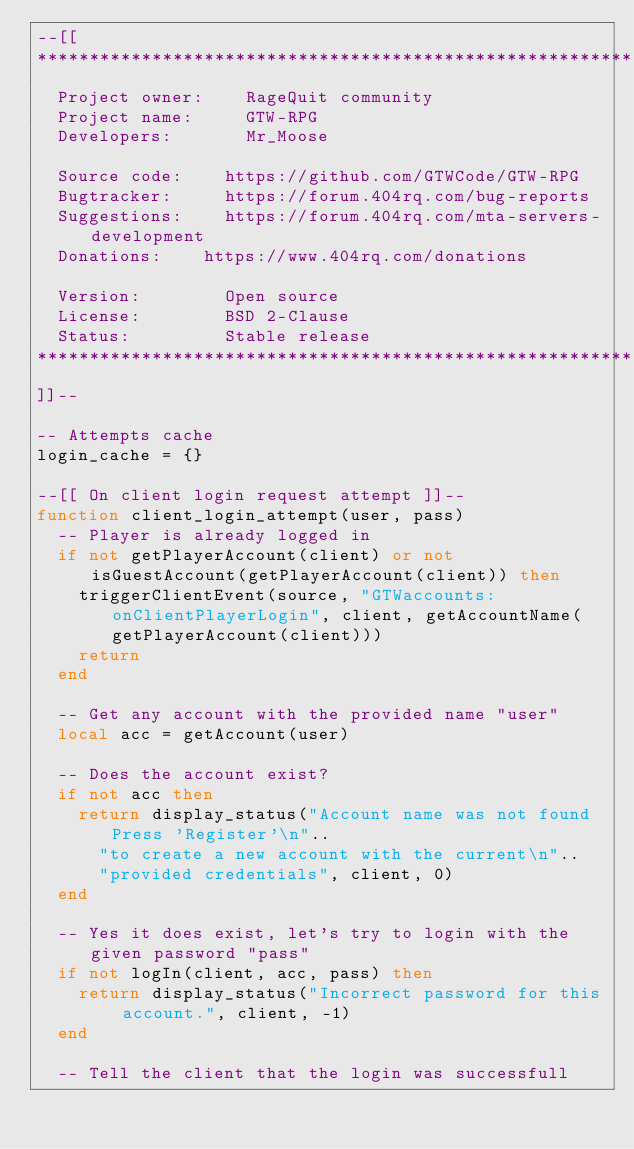<code> <loc_0><loc_0><loc_500><loc_500><_Lua_>--[[
********************************************************************************
	Project owner:		RageQuit community
	Project name: 		GTW-RPG
	Developers:   		Mr_Moose

	Source code:		https://github.com/GTWCode/GTW-RPG
	Bugtracker: 		https://forum.404rq.com/bug-reports
	Suggestions:		https://forum.404rq.com/mta-servers-development
	Donations:		https://www.404rq.com/donations

	Version:    		Open source
	License:    		BSD 2-Clause
	Status:     		Stable release
********************************************************************************
]]--

-- Attempts cache
login_cache = {}

--[[ On client login request attempt ]]--
function client_login_attempt(user, pass)
	-- Player is already logged in
	if not getPlayerAccount(client) or not isGuestAccount(getPlayerAccount(client)) then
		triggerClientEvent(source, "GTWaccounts:onClientPlayerLogin", client, getAccountName(getPlayerAccount(client)))
		return
	end

	-- Get any account with the provided name "user"
	local acc = getAccount(user)

	-- Does the account exist?
	if not acc then
		return display_status("Account name was not found Press 'Register'\n"..
			"to create a new account with the current\n"..
			"provided credentials", client, 0)
	end

	-- Yes it does exist, let's try to login with the given password "pass"
	if not logIn(client, acc, pass) then
		return display_status("Incorrect password for this account.", client, -1)
	end

	-- Tell the client that the login was successfull</code> 